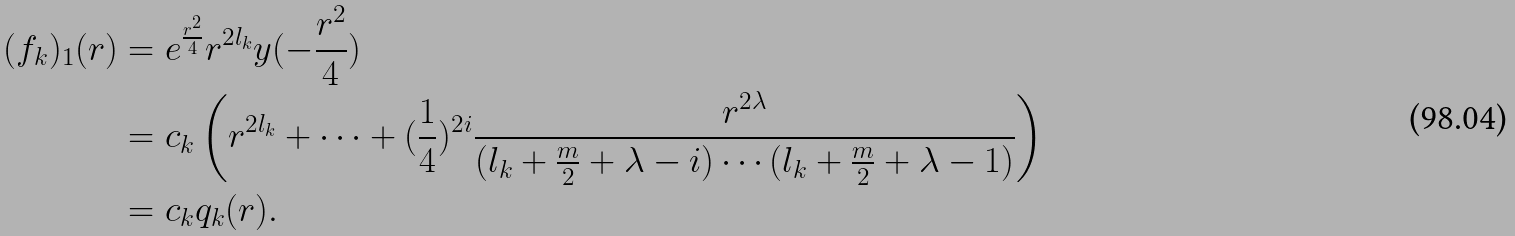Convert formula to latex. <formula><loc_0><loc_0><loc_500><loc_500>( f _ { k } ) _ { 1 } ( r ) & = e ^ { \frac { r ^ { 2 } } { 4 } } r ^ { 2 l _ { k } } y ( - \frac { r ^ { 2 } } { 4 } ) \\ & = c _ { k } \left ( r ^ { 2 l _ { k } } + \cdots + ( \frac { 1 } { 4 } ) ^ { 2 i } \frac { r ^ { 2 \lambda } } { ( l _ { k } + \frac { m } { 2 } + \lambda - i ) \cdots ( l _ { k } + \frac { m } { 2 } + \lambda - 1 ) } \right ) \\ & = c _ { k } q _ { k } ( r ) .</formula> 